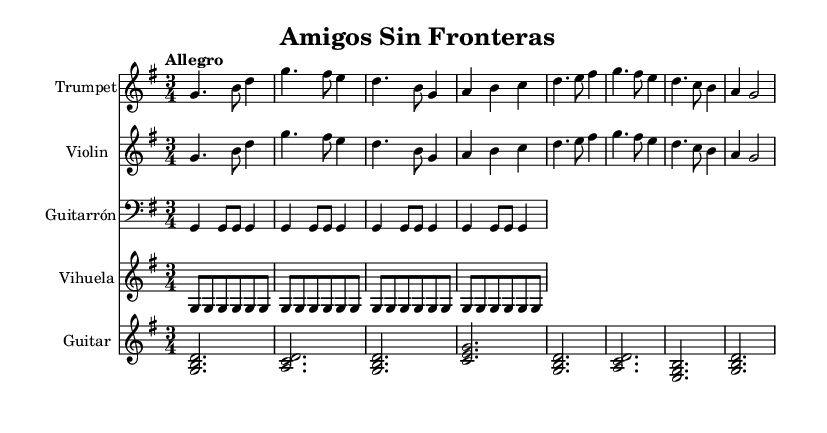What is the key signature of this music? The key signature is G major, which has one sharp (F#). This can be identified by looking at the key signature indicated at the beginning of the staff.
Answer: G major What is the time signature of the piece? The time signature is 3/4, meaning there are three beats in a measure and the quarter note gets one beat. This is indicated at the start of the score.
Answer: 3/4 What is the tempo marking for this music? The tempo marking is "Allegro," which indicates a fast and lively pace. This marking is found at the beginning of the score.
Answer: Allegro How many instruments are featured in this score? There are five instruments featured: Trumpet, Violin, Guitarrón, Vihuela, and Guitar. Each instrument has its own staff in the score.
Answer: Five What is the first lyric of the verse? The first lyric of the verse is "A - mi - gos sin fron - te - ras," which is indicated below the music lines corresponding to the trumpet part.
Answer: A - mi - gos sin fron - te - ras How many times is the G chord played in the Guitarrón part? The G chord is played four times in the Guitarrón part as indicated by the repeated notation. The structure shows the rhythm and repeat exactly four times.
Answer: Four What is the main theme expressed in the chorus? The main theme expressed in the chorus centers on unity and togetherness, indicated by the lyrics "nos u - ne la can - ción." This reflects the overarching concept of cross-border friendship.
Answer: Unity 